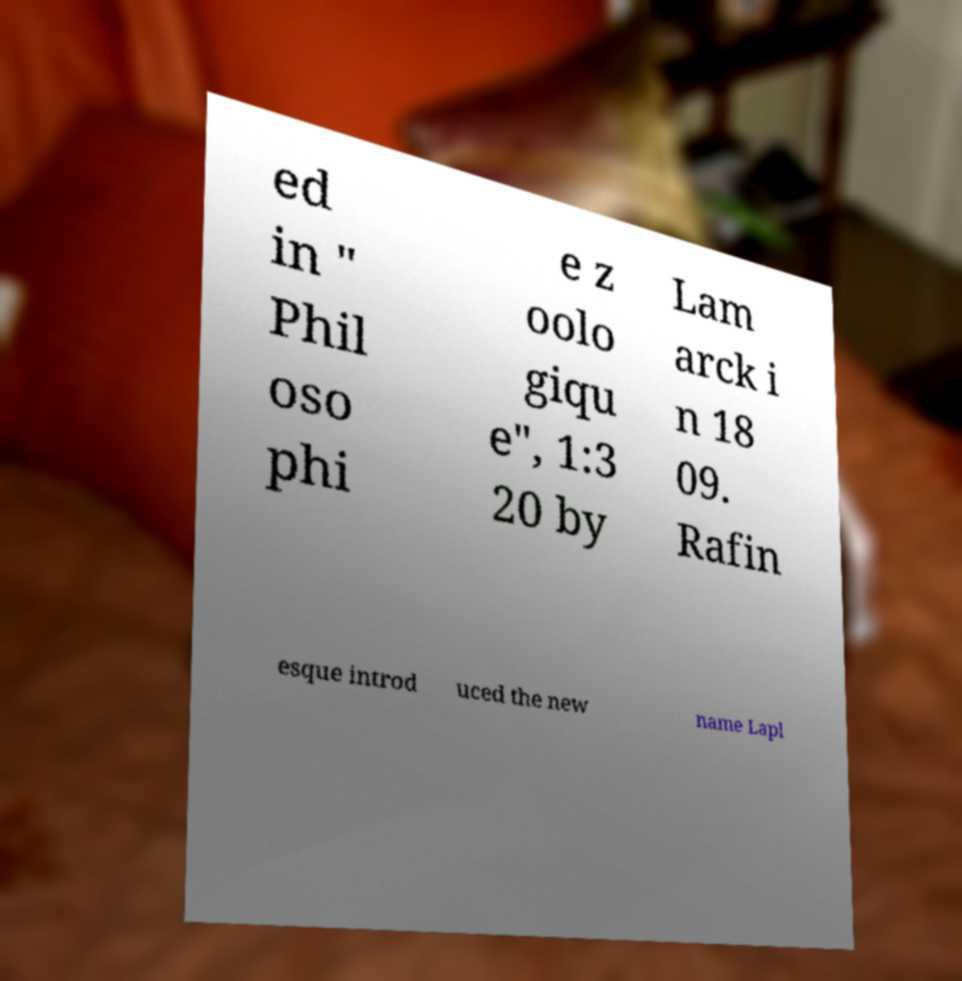There's text embedded in this image that I need extracted. Can you transcribe it verbatim? ed in " Phil oso phi e z oolo giqu e", 1:3 20 by Lam arck i n 18 09. Rafin esque introd uced the new name Lapl 